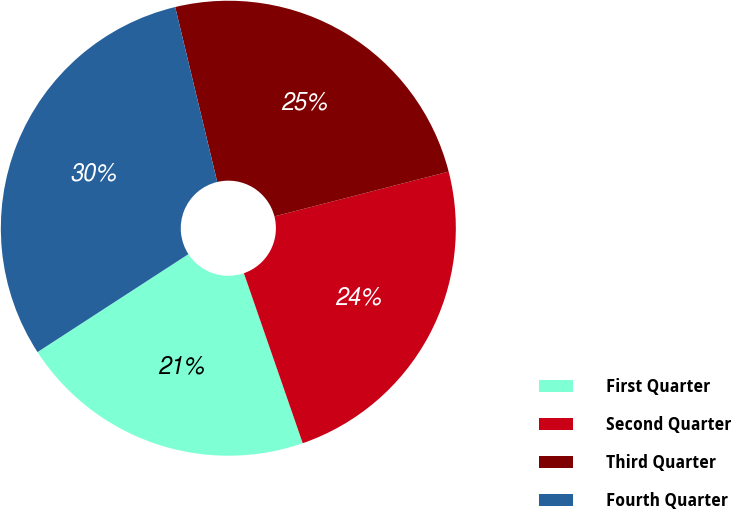Convert chart. <chart><loc_0><loc_0><loc_500><loc_500><pie_chart><fcel>First Quarter<fcel>Second Quarter<fcel>Third Quarter<fcel>Fourth Quarter<nl><fcel>21.14%<fcel>23.7%<fcel>24.75%<fcel>30.41%<nl></chart> 